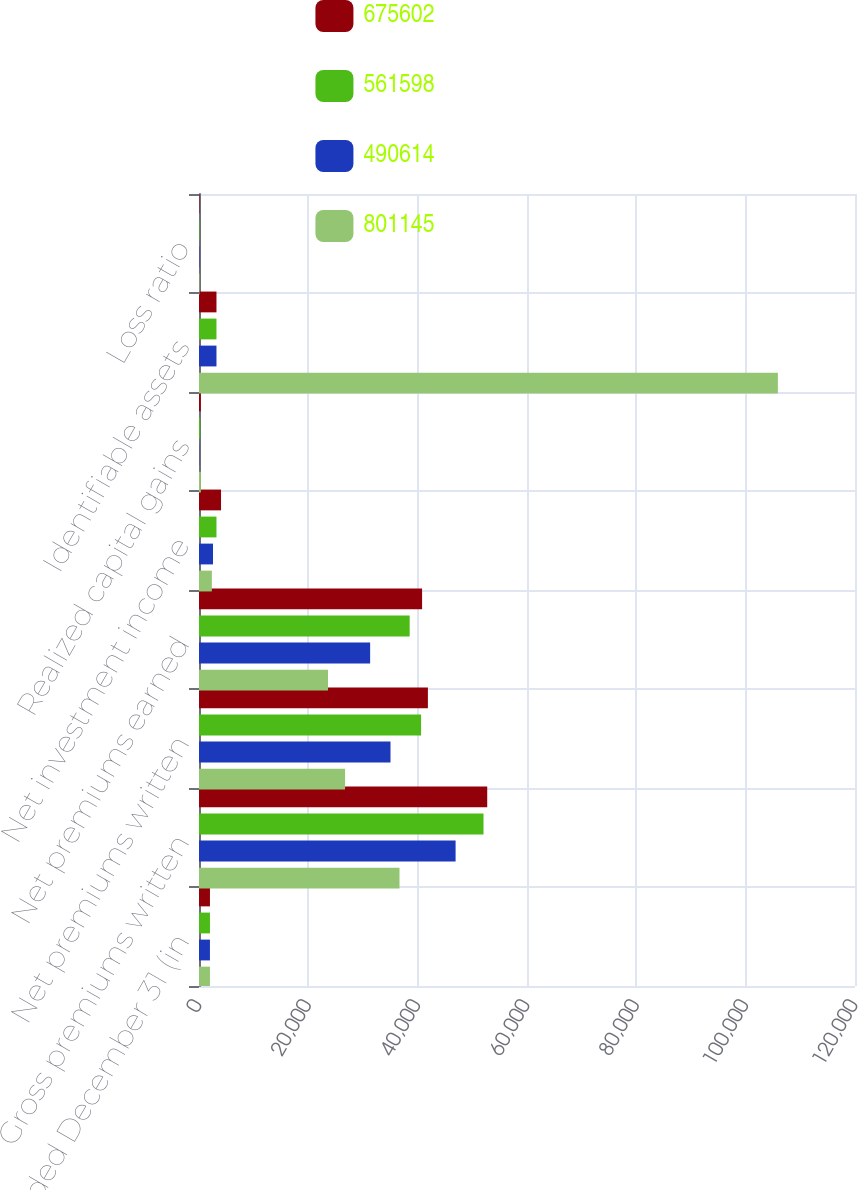<chart> <loc_0><loc_0><loc_500><loc_500><stacked_bar_chart><ecel><fcel>Years Ended December 31 (in<fcel>Gross premiums written<fcel>Net premiums written<fcel>Net premiums earned<fcel>Net investment income<fcel>Realized capital gains<fcel>Identifiable assets<fcel>Loss ratio<nl><fcel>675602<fcel>2005<fcel>52725<fcel>41872<fcel>40809<fcel>4031<fcel>334<fcel>3196<fcel>81.1<nl><fcel>561598<fcel>2004<fcel>52046<fcel>40623<fcel>38537<fcel>3196<fcel>228<fcel>3196<fcel>78.8<nl><fcel>490614<fcel>2003<fcel>46938<fcel>35031<fcel>31306<fcel>2566<fcel>39<fcel>3196<fcel>73.1<nl><fcel>801145<fcel>2002<fcel>36678<fcel>26718<fcel>23595<fcel>2350<fcel>345<fcel>105891<fcel>83.1<nl></chart> 